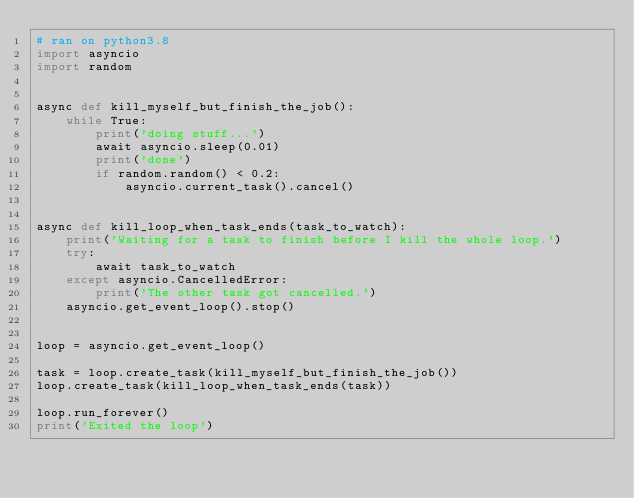Convert code to text. <code><loc_0><loc_0><loc_500><loc_500><_Python_># ran on python3.8
import asyncio
import random


async def kill_myself_but_finish_the_job():
    while True:
        print('doing stuff...')
        await asyncio.sleep(0.01)
        print('done')
        if random.random() < 0.2:
            asyncio.current_task().cancel()


async def kill_loop_when_task_ends(task_to_watch):
    print('Waiting for a task to finish before I kill the whole loop.')
    try:
        await task_to_watch
    except asyncio.CancelledError:
        print('The other task got cancelled.')
    asyncio.get_event_loop().stop()


loop = asyncio.get_event_loop()

task = loop.create_task(kill_myself_but_finish_the_job())
loop.create_task(kill_loop_when_task_ends(task))

loop.run_forever()
print('Exited the loop')
</code> 